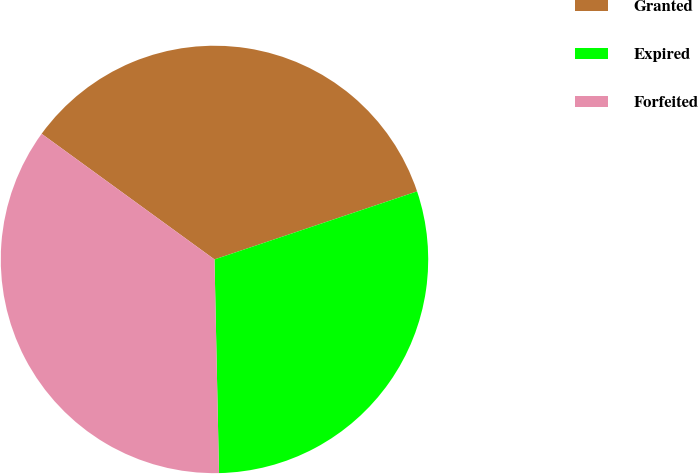<chart> <loc_0><loc_0><loc_500><loc_500><pie_chart><fcel>Granted<fcel>Expired<fcel>Forfeited<nl><fcel>34.84%<fcel>29.82%<fcel>35.34%<nl></chart> 